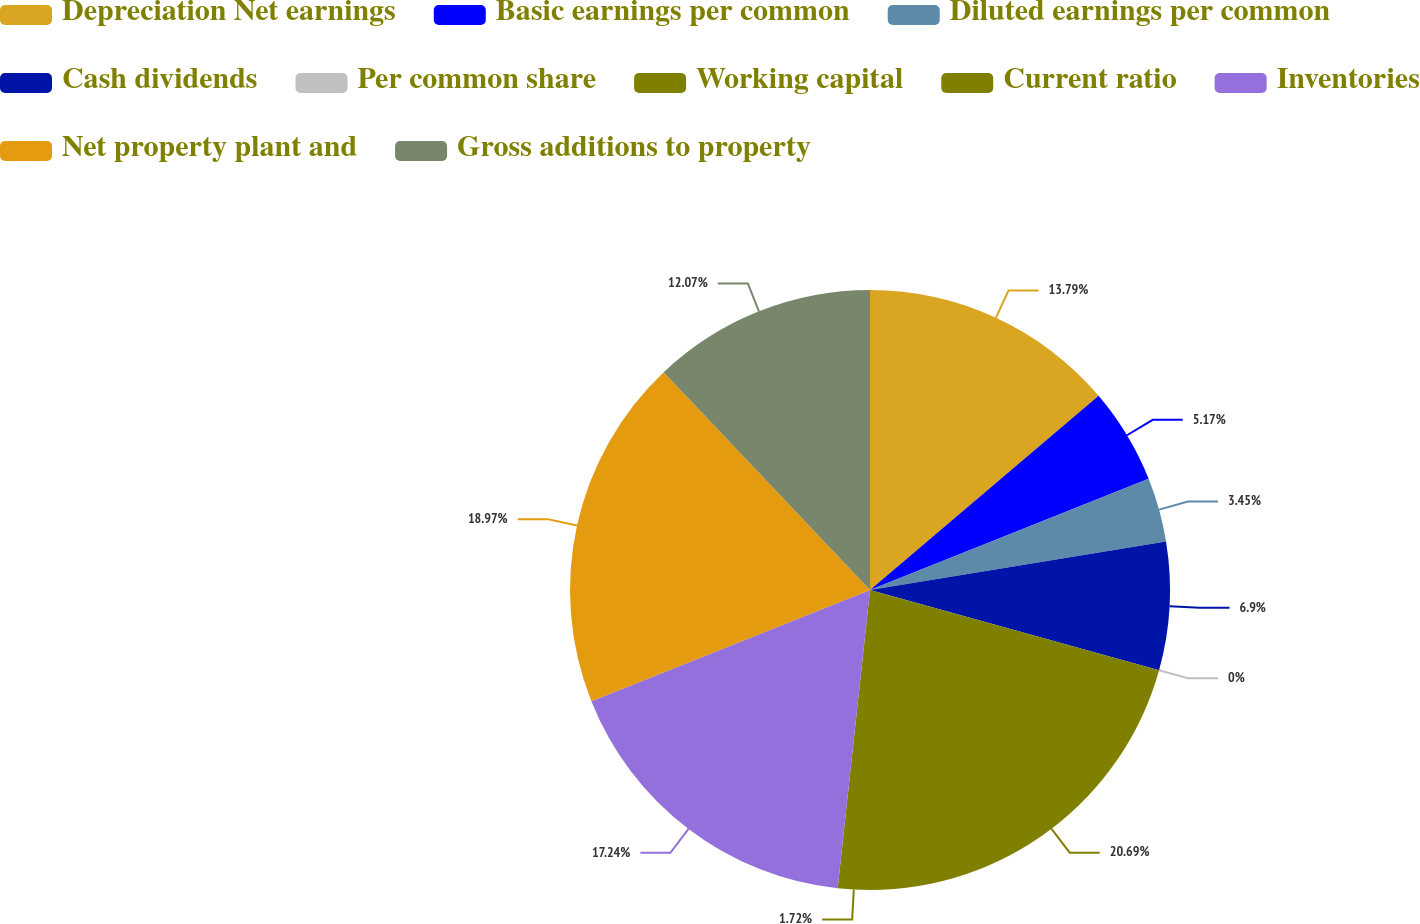<chart> <loc_0><loc_0><loc_500><loc_500><pie_chart><fcel>Depreciation Net earnings<fcel>Basic earnings per common<fcel>Diluted earnings per common<fcel>Cash dividends<fcel>Per common share<fcel>Working capital<fcel>Current ratio<fcel>Inventories<fcel>Net property plant and<fcel>Gross additions to property<nl><fcel>13.79%<fcel>5.17%<fcel>3.45%<fcel>6.9%<fcel>0.0%<fcel>20.69%<fcel>1.72%<fcel>17.24%<fcel>18.97%<fcel>12.07%<nl></chart> 